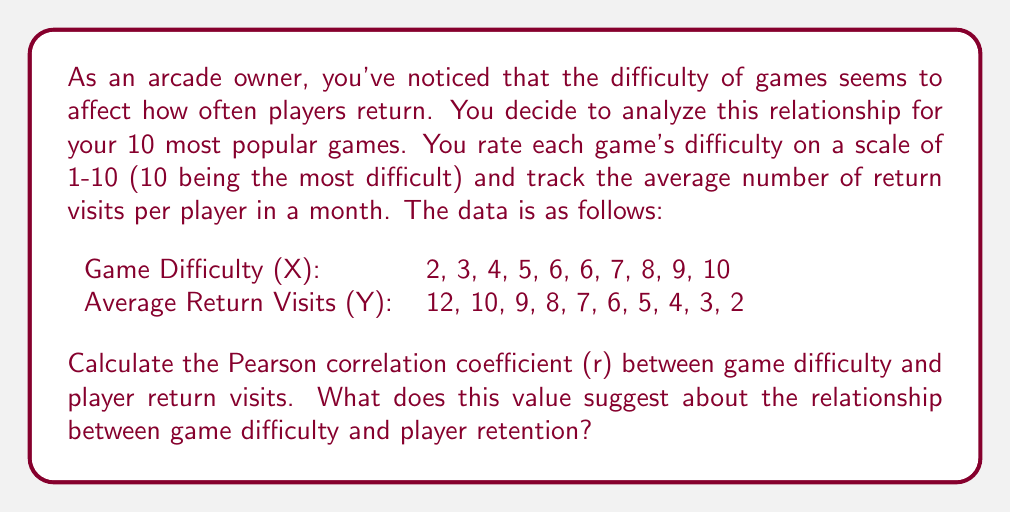Teach me how to tackle this problem. To calculate the Pearson correlation coefficient (r), we'll use the formula:

$$ r = \frac{\sum_{i=1}^{n} (x_i - \bar{x})(y_i - \bar{y})}{\sqrt{\sum_{i=1}^{n} (x_i - \bar{x})^2 \sum_{i=1}^{n} (y_i - \bar{y})^2}} $$

Where:
$x_i$ and $y_i$ are the individual values of each variable
$\bar{x}$ and $\bar{y}$ are the means of each variable
$n$ is the number of pairs of data

Step 1: Calculate the means
$\bar{x} = \frac{2 + 3 + 4 + 5 + 6 + 6 + 7 + 8 + 9 + 10}{10} = 6$
$\bar{y} = \frac{12 + 10 + 9 + 8 + 7 + 6 + 5 + 4 + 3 + 2}{10} = 6.6$

Step 2: Calculate $(x_i - \bar{x})$, $(y_i - \bar{y})$, $(x_i - \bar{x})^2$, $(y_i - \bar{y})^2$, and $(x_i - \bar{x})(y_i - \bar{y})$ for each pair

Step 3: Sum up the values from Step 2
$\sum (x_i - \bar{x})(y_i - \bar{y}) = -114$
$\sum (x_i - \bar{x})^2 = 110$
$\sum (y_i - \bar{y})^2 = 118$

Step 4: Apply the formula
$$ r = \frac{-114}{\sqrt{110 \times 118}} = \frac{-114}{113.92} = -0.9999 $$

The Pearson correlation coefficient is approximately -0.9999, which indicates a very strong negative correlation between game difficulty and player return visits.
Answer: r ≈ -0.9999

This value suggests an extremely strong negative correlation between game difficulty and player retention. As game difficulty increases, the number of return visits decreases almost perfectly linearly. This implies that easier games tend to have higher player retention rates in your arcade. 